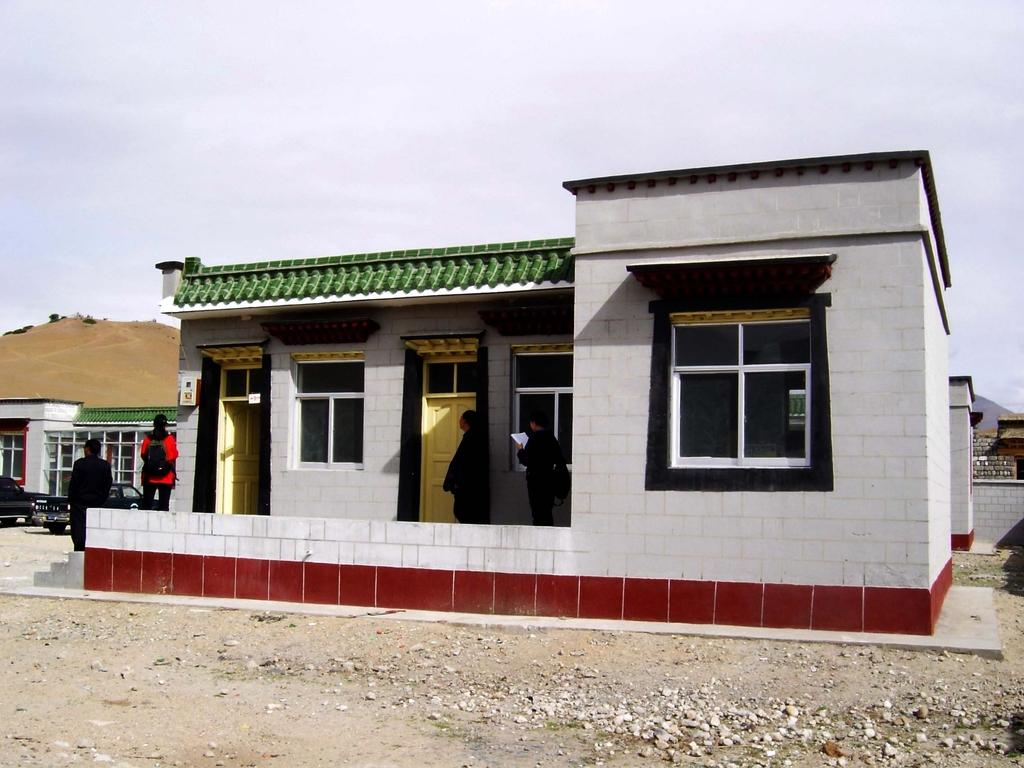What is happening in the image? There are people standing in the image. Can you describe the clothing of the person in front? The person in front is wearing a black dress. What type of building can be seen in the image? There is a white-colored building in the image. What is the color of the sky in the background? The sky in the background appears to be white. What trade agreement is being discussed by the governor in the image? There is no governor present in the image, and no trade agreement is being discussed. 